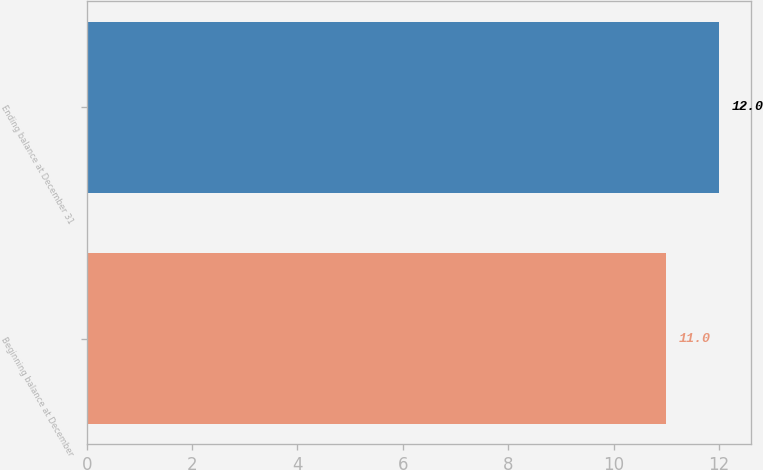Convert chart to OTSL. <chart><loc_0><loc_0><loc_500><loc_500><bar_chart><fcel>Beginning balance at December<fcel>Ending balance at December 31<nl><fcel>11<fcel>12<nl></chart> 